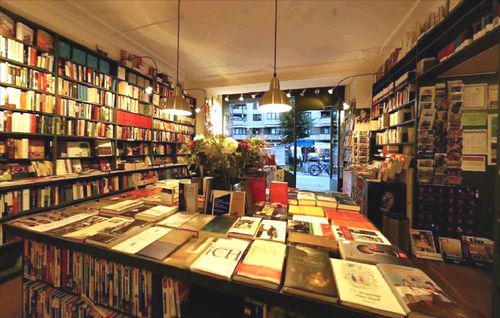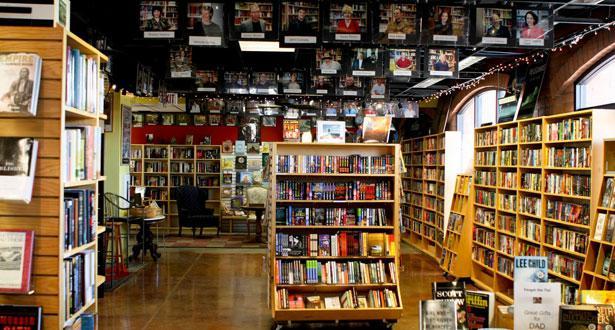The first image is the image on the left, the second image is the image on the right. For the images shown, is this caption "In at least one image there is an empty bookstore  with table that has at least 30 books on it." true? Answer yes or no. Yes. The first image is the image on the left, the second image is the image on the right. Analyze the images presented: Is the assertion "In the image on the right, there is at least one table that holds some books propped up on bookstands." valid? Answer yes or no. Yes. 